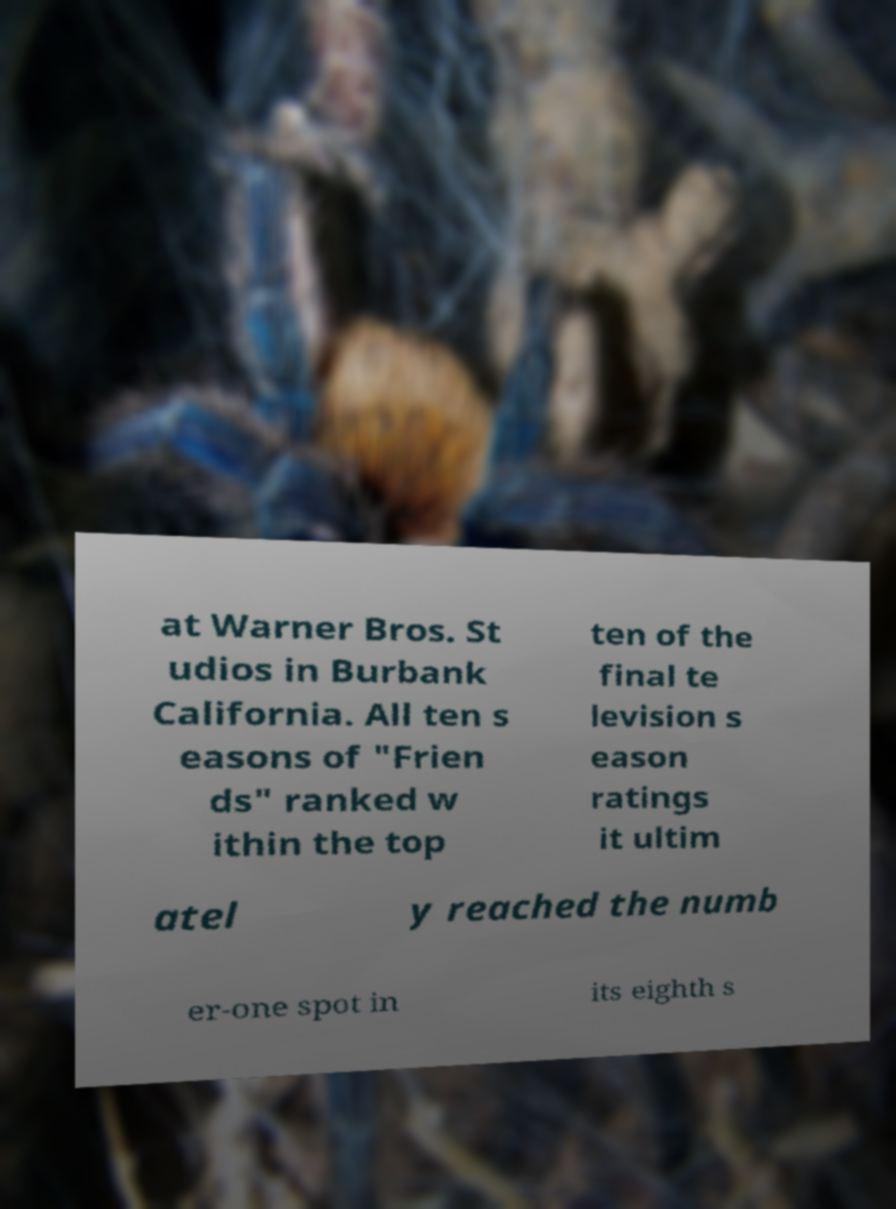Could you assist in decoding the text presented in this image and type it out clearly? at Warner Bros. St udios in Burbank California. All ten s easons of "Frien ds" ranked w ithin the top ten of the final te levision s eason ratings it ultim atel y reached the numb er-one spot in its eighth s 